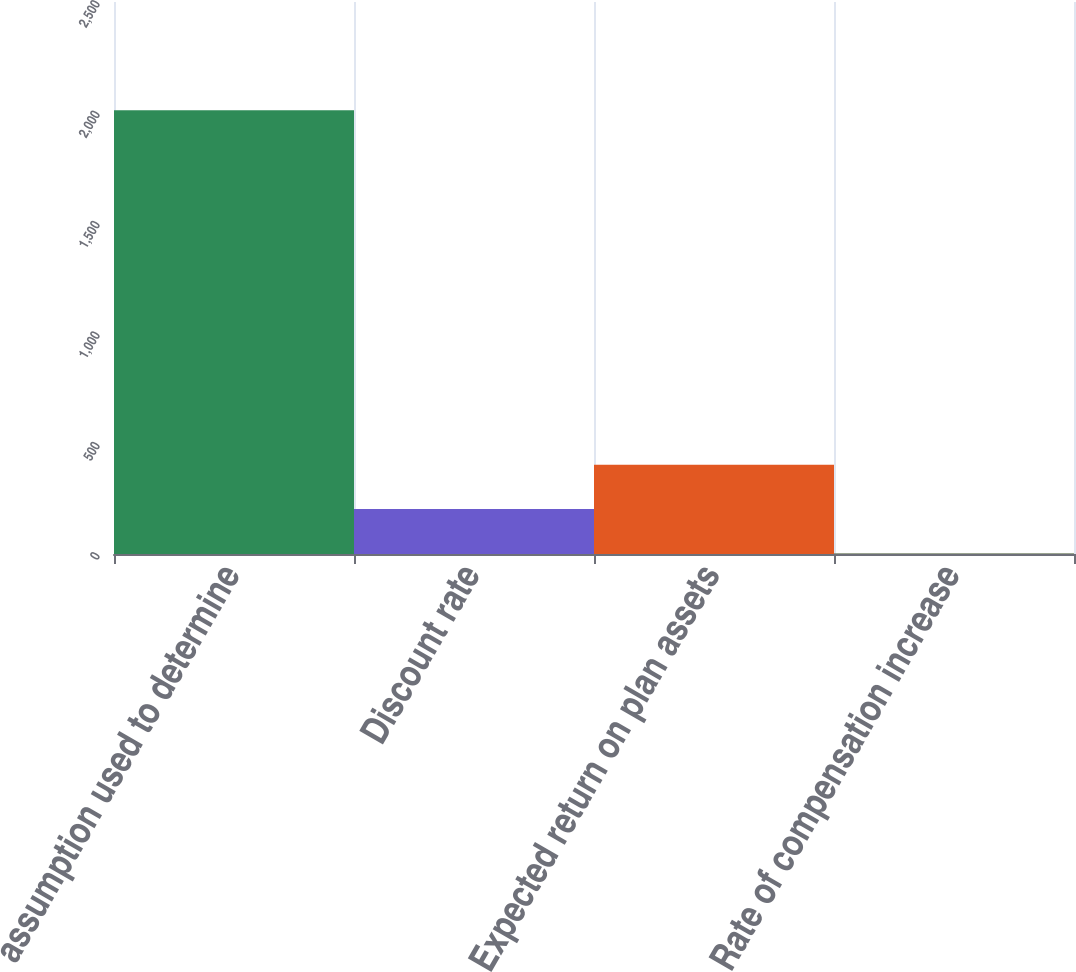Convert chart to OTSL. <chart><loc_0><loc_0><loc_500><loc_500><bar_chart><fcel>assumption used to determine<fcel>Discount rate<fcel>Expected return on plan assets<fcel>Rate of compensation increase<nl><fcel>2010<fcel>203.7<fcel>404.4<fcel>3<nl></chart> 